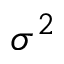Convert formula to latex. <formula><loc_0><loc_0><loc_500><loc_500>\sigma ^ { 2 }</formula> 